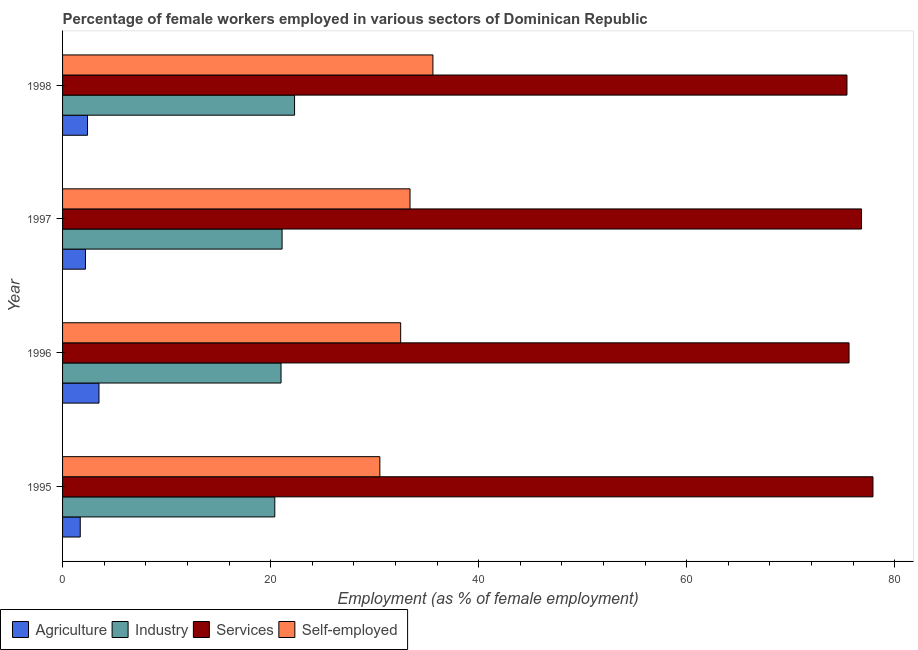How many different coloured bars are there?
Offer a very short reply. 4. How many groups of bars are there?
Your answer should be compact. 4. Are the number of bars per tick equal to the number of legend labels?
Provide a succinct answer. Yes. Are the number of bars on each tick of the Y-axis equal?
Give a very brief answer. Yes. What is the label of the 4th group of bars from the top?
Your answer should be very brief. 1995. What is the percentage of female workers in industry in 1997?
Give a very brief answer. 21.1. Across all years, what is the maximum percentage of female workers in services?
Your response must be concise. 77.9. Across all years, what is the minimum percentage of female workers in agriculture?
Your answer should be compact. 1.7. What is the total percentage of female workers in services in the graph?
Give a very brief answer. 305.7. What is the difference between the percentage of female workers in agriculture in 1997 and that in 1998?
Ensure brevity in your answer.  -0.2. What is the difference between the percentage of female workers in services in 1995 and the percentage of female workers in agriculture in 1996?
Offer a terse response. 74.4. What is the average percentage of female workers in agriculture per year?
Your response must be concise. 2.45. In the year 1998, what is the difference between the percentage of female workers in services and percentage of female workers in industry?
Ensure brevity in your answer.  53.1. In how many years, is the percentage of female workers in industry greater than 24 %?
Provide a short and direct response. 0. What is the ratio of the percentage of self employed female workers in 1995 to that in 1997?
Your response must be concise. 0.91. Is the difference between the percentage of female workers in services in 1995 and 1996 greater than the difference between the percentage of female workers in agriculture in 1995 and 1996?
Make the answer very short. Yes. What is the difference between the highest and the lowest percentage of self employed female workers?
Provide a short and direct response. 5.1. Is it the case that in every year, the sum of the percentage of female workers in agriculture and percentage of female workers in industry is greater than the sum of percentage of female workers in services and percentage of self employed female workers?
Offer a very short reply. Yes. What does the 4th bar from the top in 1995 represents?
Your response must be concise. Agriculture. What does the 2nd bar from the bottom in 1995 represents?
Ensure brevity in your answer.  Industry. How many bars are there?
Offer a terse response. 16. Are all the bars in the graph horizontal?
Offer a terse response. Yes. How many years are there in the graph?
Offer a terse response. 4. What is the difference between two consecutive major ticks on the X-axis?
Give a very brief answer. 20. Does the graph contain any zero values?
Make the answer very short. No. Where does the legend appear in the graph?
Provide a short and direct response. Bottom left. What is the title of the graph?
Offer a very short reply. Percentage of female workers employed in various sectors of Dominican Republic. What is the label or title of the X-axis?
Offer a very short reply. Employment (as % of female employment). What is the label or title of the Y-axis?
Your answer should be very brief. Year. What is the Employment (as % of female employment) in Agriculture in 1995?
Ensure brevity in your answer.  1.7. What is the Employment (as % of female employment) of Industry in 1995?
Your response must be concise. 20.4. What is the Employment (as % of female employment) of Services in 1995?
Offer a very short reply. 77.9. What is the Employment (as % of female employment) in Self-employed in 1995?
Keep it short and to the point. 30.5. What is the Employment (as % of female employment) in Services in 1996?
Ensure brevity in your answer.  75.6. What is the Employment (as % of female employment) of Self-employed in 1996?
Your answer should be compact. 32.5. What is the Employment (as % of female employment) of Agriculture in 1997?
Give a very brief answer. 2.2. What is the Employment (as % of female employment) in Industry in 1997?
Your answer should be compact. 21.1. What is the Employment (as % of female employment) of Services in 1997?
Keep it short and to the point. 76.8. What is the Employment (as % of female employment) of Self-employed in 1997?
Keep it short and to the point. 33.4. What is the Employment (as % of female employment) in Agriculture in 1998?
Your answer should be very brief. 2.4. What is the Employment (as % of female employment) in Industry in 1998?
Your response must be concise. 22.3. What is the Employment (as % of female employment) of Services in 1998?
Offer a very short reply. 75.4. What is the Employment (as % of female employment) in Self-employed in 1998?
Your answer should be very brief. 35.6. Across all years, what is the maximum Employment (as % of female employment) of Agriculture?
Your response must be concise. 3.5. Across all years, what is the maximum Employment (as % of female employment) in Industry?
Your answer should be very brief. 22.3. Across all years, what is the maximum Employment (as % of female employment) of Services?
Offer a terse response. 77.9. Across all years, what is the maximum Employment (as % of female employment) in Self-employed?
Make the answer very short. 35.6. Across all years, what is the minimum Employment (as % of female employment) in Agriculture?
Ensure brevity in your answer.  1.7. Across all years, what is the minimum Employment (as % of female employment) in Industry?
Make the answer very short. 20.4. Across all years, what is the minimum Employment (as % of female employment) of Services?
Give a very brief answer. 75.4. Across all years, what is the minimum Employment (as % of female employment) of Self-employed?
Provide a short and direct response. 30.5. What is the total Employment (as % of female employment) in Agriculture in the graph?
Offer a terse response. 9.8. What is the total Employment (as % of female employment) of Industry in the graph?
Your answer should be compact. 84.8. What is the total Employment (as % of female employment) of Services in the graph?
Offer a terse response. 305.7. What is the total Employment (as % of female employment) in Self-employed in the graph?
Offer a terse response. 132. What is the difference between the Employment (as % of female employment) in Services in 1995 and that in 1997?
Offer a terse response. 1.1. What is the difference between the Employment (as % of female employment) of Self-employed in 1995 and that in 1997?
Keep it short and to the point. -2.9. What is the difference between the Employment (as % of female employment) in Agriculture in 1995 and that in 1998?
Your response must be concise. -0.7. What is the difference between the Employment (as % of female employment) of Self-employed in 1995 and that in 1998?
Offer a very short reply. -5.1. What is the difference between the Employment (as % of female employment) in Agriculture in 1996 and that in 1997?
Keep it short and to the point. 1.3. What is the difference between the Employment (as % of female employment) of Industry in 1996 and that in 1997?
Provide a succinct answer. -0.1. What is the difference between the Employment (as % of female employment) in Services in 1996 and that in 1997?
Provide a short and direct response. -1.2. What is the difference between the Employment (as % of female employment) in Agriculture in 1996 and that in 1998?
Provide a short and direct response. 1.1. What is the difference between the Employment (as % of female employment) in Industry in 1996 and that in 1998?
Offer a very short reply. -1.3. What is the difference between the Employment (as % of female employment) in Services in 1996 and that in 1998?
Ensure brevity in your answer.  0.2. What is the difference between the Employment (as % of female employment) in Self-employed in 1996 and that in 1998?
Give a very brief answer. -3.1. What is the difference between the Employment (as % of female employment) in Agriculture in 1997 and that in 1998?
Your answer should be compact. -0.2. What is the difference between the Employment (as % of female employment) in Industry in 1997 and that in 1998?
Give a very brief answer. -1.2. What is the difference between the Employment (as % of female employment) of Services in 1997 and that in 1998?
Give a very brief answer. 1.4. What is the difference between the Employment (as % of female employment) of Self-employed in 1997 and that in 1998?
Provide a succinct answer. -2.2. What is the difference between the Employment (as % of female employment) in Agriculture in 1995 and the Employment (as % of female employment) in Industry in 1996?
Ensure brevity in your answer.  -19.3. What is the difference between the Employment (as % of female employment) in Agriculture in 1995 and the Employment (as % of female employment) in Services in 1996?
Give a very brief answer. -73.9. What is the difference between the Employment (as % of female employment) in Agriculture in 1995 and the Employment (as % of female employment) in Self-employed in 1996?
Give a very brief answer. -30.8. What is the difference between the Employment (as % of female employment) in Industry in 1995 and the Employment (as % of female employment) in Services in 1996?
Provide a short and direct response. -55.2. What is the difference between the Employment (as % of female employment) in Industry in 1995 and the Employment (as % of female employment) in Self-employed in 1996?
Offer a terse response. -12.1. What is the difference between the Employment (as % of female employment) in Services in 1995 and the Employment (as % of female employment) in Self-employed in 1996?
Make the answer very short. 45.4. What is the difference between the Employment (as % of female employment) of Agriculture in 1995 and the Employment (as % of female employment) of Industry in 1997?
Keep it short and to the point. -19.4. What is the difference between the Employment (as % of female employment) in Agriculture in 1995 and the Employment (as % of female employment) in Services in 1997?
Give a very brief answer. -75.1. What is the difference between the Employment (as % of female employment) of Agriculture in 1995 and the Employment (as % of female employment) of Self-employed in 1997?
Your response must be concise. -31.7. What is the difference between the Employment (as % of female employment) of Industry in 1995 and the Employment (as % of female employment) of Services in 1997?
Keep it short and to the point. -56.4. What is the difference between the Employment (as % of female employment) of Services in 1995 and the Employment (as % of female employment) of Self-employed in 1997?
Give a very brief answer. 44.5. What is the difference between the Employment (as % of female employment) in Agriculture in 1995 and the Employment (as % of female employment) in Industry in 1998?
Provide a short and direct response. -20.6. What is the difference between the Employment (as % of female employment) of Agriculture in 1995 and the Employment (as % of female employment) of Services in 1998?
Provide a succinct answer. -73.7. What is the difference between the Employment (as % of female employment) in Agriculture in 1995 and the Employment (as % of female employment) in Self-employed in 1998?
Your answer should be compact. -33.9. What is the difference between the Employment (as % of female employment) of Industry in 1995 and the Employment (as % of female employment) of Services in 1998?
Make the answer very short. -55. What is the difference between the Employment (as % of female employment) in Industry in 1995 and the Employment (as % of female employment) in Self-employed in 1998?
Offer a very short reply. -15.2. What is the difference between the Employment (as % of female employment) of Services in 1995 and the Employment (as % of female employment) of Self-employed in 1998?
Your response must be concise. 42.3. What is the difference between the Employment (as % of female employment) in Agriculture in 1996 and the Employment (as % of female employment) in Industry in 1997?
Keep it short and to the point. -17.6. What is the difference between the Employment (as % of female employment) of Agriculture in 1996 and the Employment (as % of female employment) of Services in 1997?
Give a very brief answer. -73.3. What is the difference between the Employment (as % of female employment) of Agriculture in 1996 and the Employment (as % of female employment) of Self-employed in 1997?
Provide a short and direct response. -29.9. What is the difference between the Employment (as % of female employment) of Industry in 1996 and the Employment (as % of female employment) of Services in 1997?
Make the answer very short. -55.8. What is the difference between the Employment (as % of female employment) in Industry in 1996 and the Employment (as % of female employment) in Self-employed in 1997?
Offer a terse response. -12.4. What is the difference between the Employment (as % of female employment) in Services in 1996 and the Employment (as % of female employment) in Self-employed in 1997?
Ensure brevity in your answer.  42.2. What is the difference between the Employment (as % of female employment) of Agriculture in 1996 and the Employment (as % of female employment) of Industry in 1998?
Offer a terse response. -18.8. What is the difference between the Employment (as % of female employment) of Agriculture in 1996 and the Employment (as % of female employment) of Services in 1998?
Make the answer very short. -71.9. What is the difference between the Employment (as % of female employment) in Agriculture in 1996 and the Employment (as % of female employment) in Self-employed in 1998?
Offer a terse response. -32.1. What is the difference between the Employment (as % of female employment) of Industry in 1996 and the Employment (as % of female employment) of Services in 1998?
Make the answer very short. -54.4. What is the difference between the Employment (as % of female employment) of Industry in 1996 and the Employment (as % of female employment) of Self-employed in 1998?
Provide a succinct answer. -14.6. What is the difference between the Employment (as % of female employment) in Agriculture in 1997 and the Employment (as % of female employment) in Industry in 1998?
Your answer should be compact. -20.1. What is the difference between the Employment (as % of female employment) of Agriculture in 1997 and the Employment (as % of female employment) of Services in 1998?
Your answer should be compact. -73.2. What is the difference between the Employment (as % of female employment) in Agriculture in 1997 and the Employment (as % of female employment) in Self-employed in 1998?
Provide a short and direct response. -33.4. What is the difference between the Employment (as % of female employment) of Industry in 1997 and the Employment (as % of female employment) of Services in 1998?
Provide a succinct answer. -54.3. What is the difference between the Employment (as % of female employment) in Services in 1997 and the Employment (as % of female employment) in Self-employed in 1998?
Your response must be concise. 41.2. What is the average Employment (as % of female employment) of Agriculture per year?
Offer a very short reply. 2.45. What is the average Employment (as % of female employment) of Industry per year?
Ensure brevity in your answer.  21.2. What is the average Employment (as % of female employment) in Services per year?
Keep it short and to the point. 76.42. What is the average Employment (as % of female employment) of Self-employed per year?
Keep it short and to the point. 33. In the year 1995, what is the difference between the Employment (as % of female employment) in Agriculture and Employment (as % of female employment) in Industry?
Ensure brevity in your answer.  -18.7. In the year 1995, what is the difference between the Employment (as % of female employment) of Agriculture and Employment (as % of female employment) of Services?
Offer a very short reply. -76.2. In the year 1995, what is the difference between the Employment (as % of female employment) of Agriculture and Employment (as % of female employment) of Self-employed?
Your answer should be compact. -28.8. In the year 1995, what is the difference between the Employment (as % of female employment) in Industry and Employment (as % of female employment) in Services?
Make the answer very short. -57.5. In the year 1995, what is the difference between the Employment (as % of female employment) in Services and Employment (as % of female employment) in Self-employed?
Offer a very short reply. 47.4. In the year 1996, what is the difference between the Employment (as % of female employment) in Agriculture and Employment (as % of female employment) in Industry?
Offer a very short reply. -17.5. In the year 1996, what is the difference between the Employment (as % of female employment) in Agriculture and Employment (as % of female employment) in Services?
Provide a short and direct response. -72.1. In the year 1996, what is the difference between the Employment (as % of female employment) in Industry and Employment (as % of female employment) in Services?
Offer a very short reply. -54.6. In the year 1996, what is the difference between the Employment (as % of female employment) of Industry and Employment (as % of female employment) of Self-employed?
Give a very brief answer. -11.5. In the year 1996, what is the difference between the Employment (as % of female employment) of Services and Employment (as % of female employment) of Self-employed?
Your answer should be very brief. 43.1. In the year 1997, what is the difference between the Employment (as % of female employment) of Agriculture and Employment (as % of female employment) of Industry?
Provide a succinct answer. -18.9. In the year 1997, what is the difference between the Employment (as % of female employment) in Agriculture and Employment (as % of female employment) in Services?
Provide a succinct answer. -74.6. In the year 1997, what is the difference between the Employment (as % of female employment) in Agriculture and Employment (as % of female employment) in Self-employed?
Offer a very short reply. -31.2. In the year 1997, what is the difference between the Employment (as % of female employment) of Industry and Employment (as % of female employment) of Services?
Keep it short and to the point. -55.7. In the year 1997, what is the difference between the Employment (as % of female employment) of Industry and Employment (as % of female employment) of Self-employed?
Your answer should be compact. -12.3. In the year 1997, what is the difference between the Employment (as % of female employment) of Services and Employment (as % of female employment) of Self-employed?
Your answer should be very brief. 43.4. In the year 1998, what is the difference between the Employment (as % of female employment) in Agriculture and Employment (as % of female employment) in Industry?
Your answer should be very brief. -19.9. In the year 1998, what is the difference between the Employment (as % of female employment) of Agriculture and Employment (as % of female employment) of Services?
Ensure brevity in your answer.  -73. In the year 1998, what is the difference between the Employment (as % of female employment) of Agriculture and Employment (as % of female employment) of Self-employed?
Keep it short and to the point. -33.2. In the year 1998, what is the difference between the Employment (as % of female employment) in Industry and Employment (as % of female employment) in Services?
Keep it short and to the point. -53.1. In the year 1998, what is the difference between the Employment (as % of female employment) in Industry and Employment (as % of female employment) in Self-employed?
Keep it short and to the point. -13.3. In the year 1998, what is the difference between the Employment (as % of female employment) of Services and Employment (as % of female employment) of Self-employed?
Offer a very short reply. 39.8. What is the ratio of the Employment (as % of female employment) of Agriculture in 1995 to that in 1996?
Ensure brevity in your answer.  0.49. What is the ratio of the Employment (as % of female employment) of Industry in 1995 to that in 1996?
Offer a very short reply. 0.97. What is the ratio of the Employment (as % of female employment) in Services in 1995 to that in 1996?
Your answer should be very brief. 1.03. What is the ratio of the Employment (as % of female employment) of Self-employed in 1995 to that in 1996?
Ensure brevity in your answer.  0.94. What is the ratio of the Employment (as % of female employment) in Agriculture in 1995 to that in 1997?
Your answer should be very brief. 0.77. What is the ratio of the Employment (as % of female employment) in Industry in 1995 to that in 1997?
Keep it short and to the point. 0.97. What is the ratio of the Employment (as % of female employment) of Services in 1995 to that in 1997?
Your answer should be compact. 1.01. What is the ratio of the Employment (as % of female employment) of Self-employed in 1995 to that in 1997?
Your response must be concise. 0.91. What is the ratio of the Employment (as % of female employment) in Agriculture in 1995 to that in 1998?
Provide a succinct answer. 0.71. What is the ratio of the Employment (as % of female employment) of Industry in 1995 to that in 1998?
Provide a succinct answer. 0.91. What is the ratio of the Employment (as % of female employment) of Services in 1995 to that in 1998?
Provide a short and direct response. 1.03. What is the ratio of the Employment (as % of female employment) of Self-employed in 1995 to that in 1998?
Your response must be concise. 0.86. What is the ratio of the Employment (as % of female employment) in Agriculture in 1996 to that in 1997?
Your response must be concise. 1.59. What is the ratio of the Employment (as % of female employment) of Industry in 1996 to that in 1997?
Your answer should be compact. 1. What is the ratio of the Employment (as % of female employment) in Services in 1996 to that in 1997?
Offer a terse response. 0.98. What is the ratio of the Employment (as % of female employment) in Self-employed in 1996 to that in 1997?
Provide a succinct answer. 0.97. What is the ratio of the Employment (as % of female employment) in Agriculture in 1996 to that in 1998?
Ensure brevity in your answer.  1.46. What is the ratio of the Employment (as % of female employment) of Industry in 1996 to that in 1998?
Keep it short and to the point. 0.94. What is the ratio of the Employment (as % of female employment) of Self-employed in 1996 to that in 1998?
Your answer should be very brief. 0.91. What is the ratio of the Employment (as % of female employment) of Agriculture in 1997 to that in 1998?
Provide a succinct answer. 0.92. What is the ratio of the Employment (as % of female employment) in Industry in 1997 to that in 1998?
Your response must be concise. 0.95. What is the ratio of the Employment (as % of female employment) in Services in 1997 to that in 1998?
Keep it short and to the point. 1.02. What is the ratio of the Employment (as % of female employment) of Self-employed in 1997 to that in 1998?
Provide a succinct answer. 0.94. What is the difference between the highest and the second highest Employment (as % of female employment) in Industry?
Give a very brief answer. 1.2. What is the difference between the highest and the second highest Employment (as % of female employment) in Services?
Offer a terse response. 1.1. What is the difference between the highest and the second highest Employment (as % of female employment) in Self-employed?
Provide a succinct answer. 2.2. What is the difference between the highest and the lowest Employment (as % of female employment) of Agriculture?
Provide a succinct answer. 1.8. What is the difference between the highest and the lowest Employment (as % of female employment) of Self-employed?
Offer a very short reply. 5.1. 